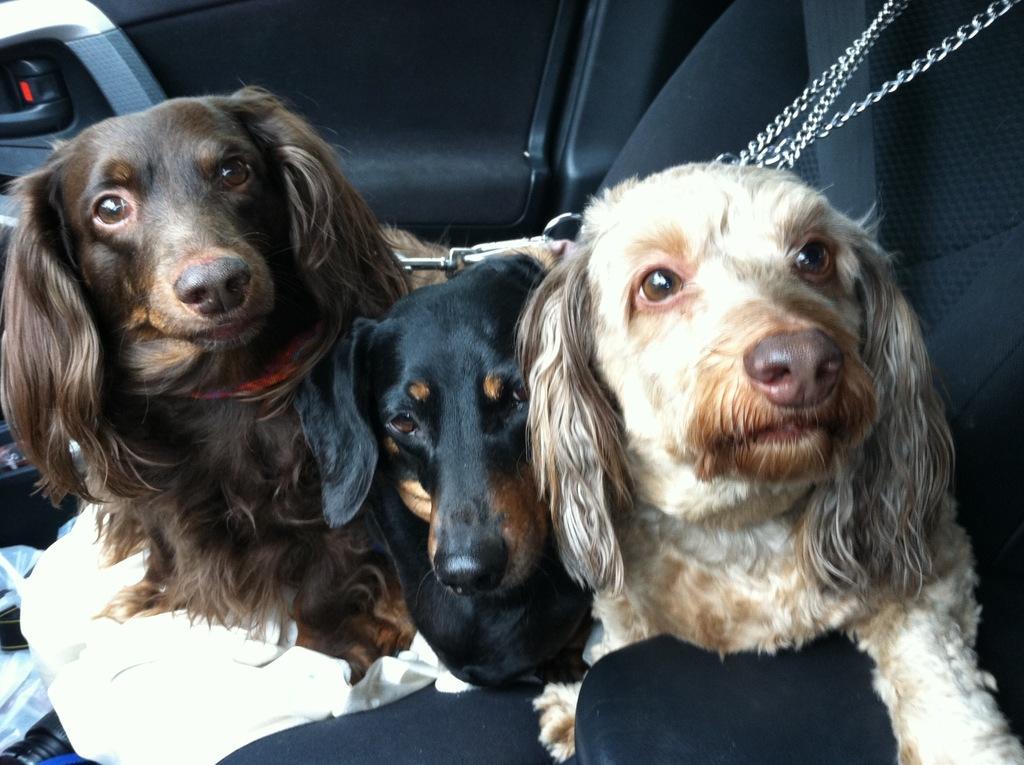Can you describe this image briefly? In this picture we can see some dogs are in the vehicle and attached with the chain. 